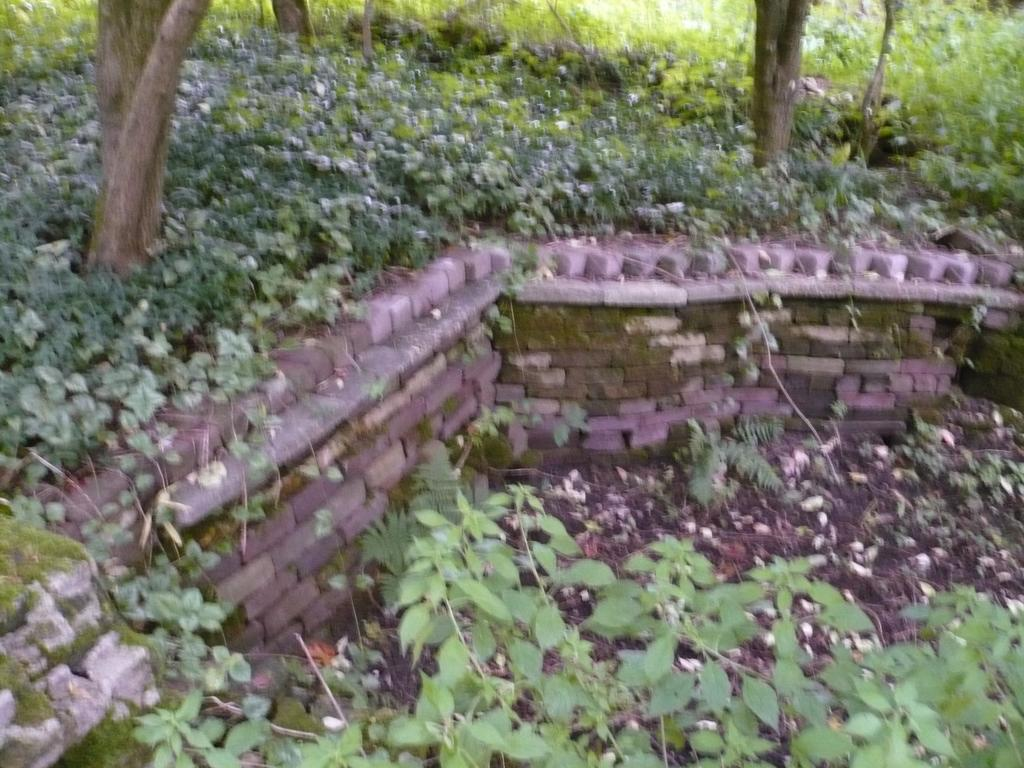What type of structure can be seen in the image? There is a small wall in the image. What type of vegetation is present in the image? There are many small bushes and tall trees in the image. Where are the tall trees located in relation to the wall? The tall trees are above the wall in the image. What type of ground cover is present below the wall? There are plants and soil below the wall in the image. What type of ornament is hanging from the tall trees in the image? There is no ornament hanging from the tall trees in the image; only plants and trees are present. How does the sleet affect the small bushes in the image? There is no mention of sleet in the image, so we cannot determine its effect on the small bushes. 